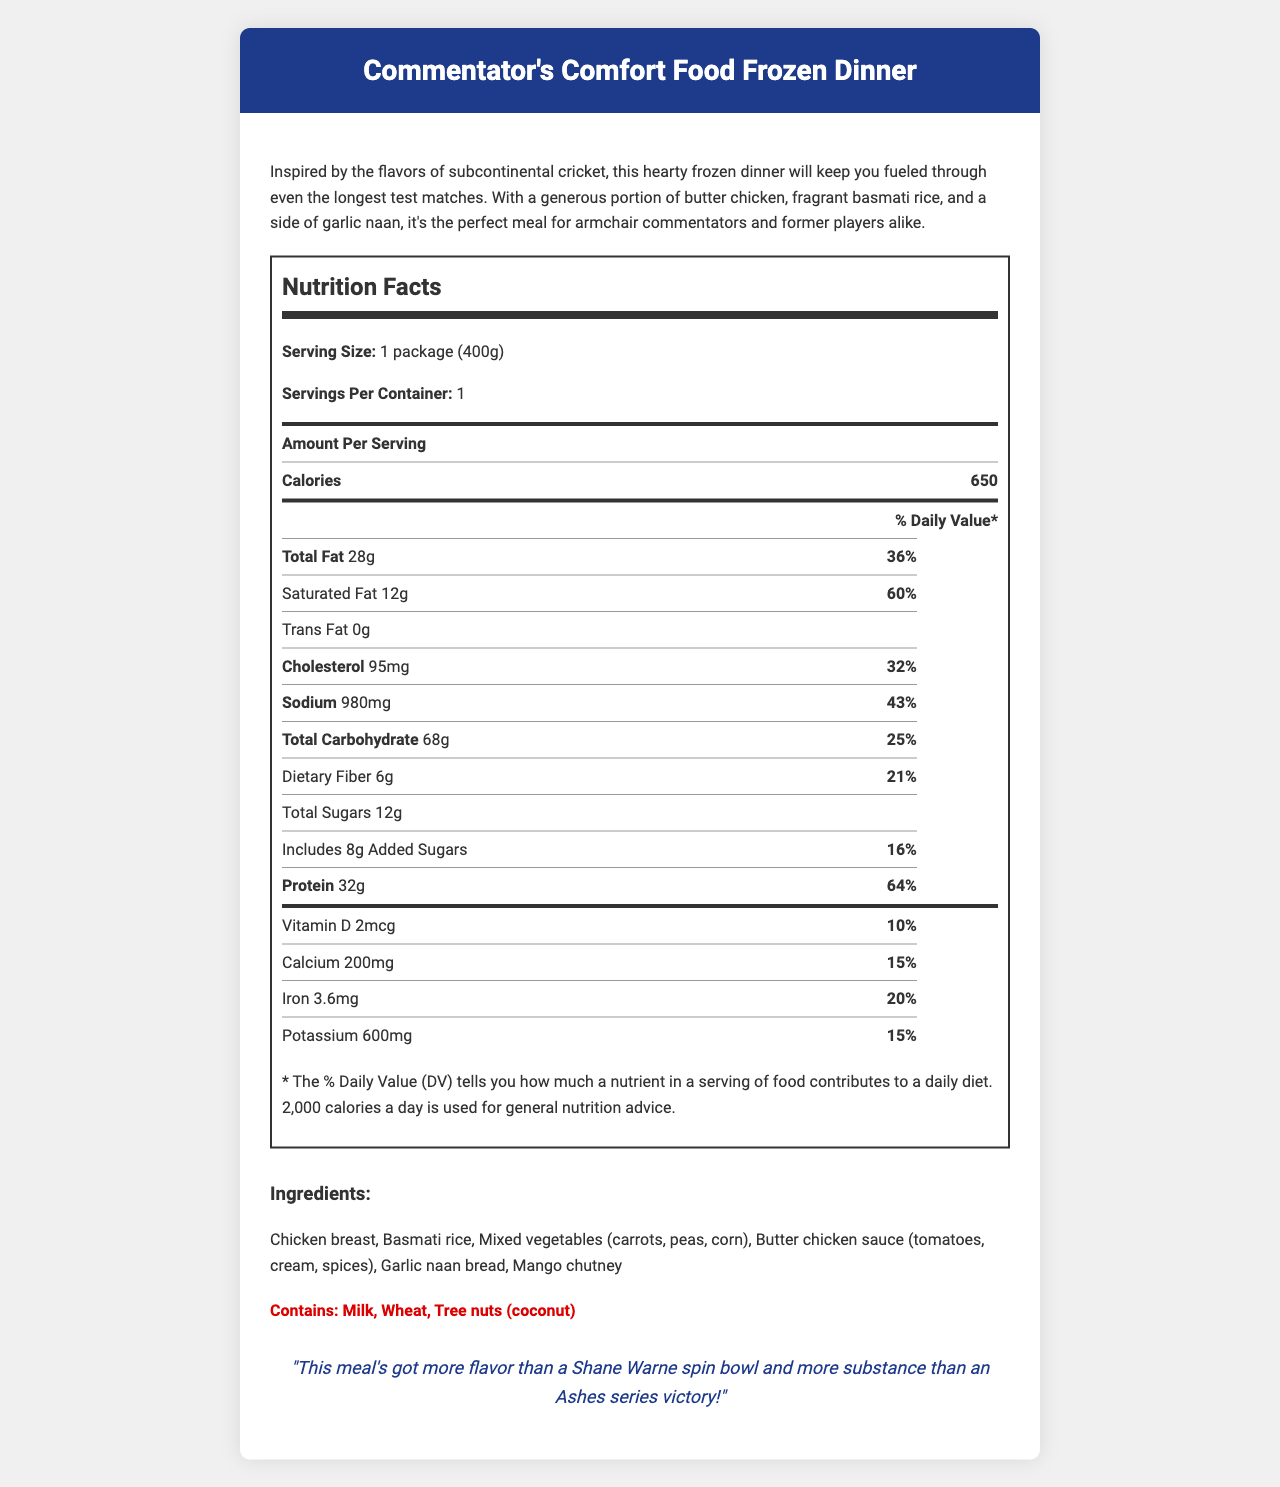what is the serving size of the frozen dinner? The document states the serving size is "1 package (400g)."
Answer: 1 package (400g) how many calories does one serving of the frozen dinner provide? The document lists the calorie content per serving as 650 calories.
Answer: 650 how much total fat is in the frozen dinner? The document indicates that there are 28 grams of total fat in one serving.
Answer: 28g what percentage of daily value does saturated fat constitute? The document specifies that the daily value percentage of saturated fat is 60%.
Answer: 60% what are the main ingredients in the frozen dinner? The document lists these items as ingredients under the ingredients section.
Answer: Chicken breast, Basmati rice, Mixed vegetables (carrots, peas, corn), Butter chicken sauce (tomatoes, cream, spices), Garlic naan bread, Mango chutney which nutrient has the highest daily value percentage? A. Saturated Fat B. Cholesterol C. Sodium D. Protein Nutrient daily values listed are Saturated Fat (60%), Cholesterol (32%), Sodium (43%), and Protein (64%). Protein has the highest daily value percentage at 64%.
Answer: D. Protein how many grams of dietary fiber does the frozen dinner provide? A. 5g B. 6g C. 7g D. 8g The document shows that the frozen dinner contains 6 grams of dietary fiber.
Answer: B. 6g does the frozen dinner contain any trans fat? The document specifies that the trans fat content is 0 grams.
Answer: No summarize the document's main idea. The document outlines the nutritional content, daily value percentages, ingredients, and allergens of the frozen dinner, alongside a humorous commentary quip and a product description emphasizing its rich flavors and substantial portion size.
Answer: The document provides detailed nutrition facts, ingredients, allergens, and a product description of the "Commentator's Comfort Food Frozen Dinner," which is inspired by subcontinental cricket flavors. how many grams of added sugars are in the frozen dinner? The document states that there are 8 grams of added sugars in the frozen dinner.
Answer: 8g how much potassium is in the frozen dinner in mg and what is the daily value percentage? The document lists 600 mg of potassium which constitutes 15% of the daily value.
Answer: 600 mg, 15% what allergens are present in the frozen dinner? The document mentions these allergens in the allergen section.
Answer: Milk, Wheat, Tree nuts (coconut) what type of rice is included in the frozen dinner? The ingredients section lists Basmati rice as part of the dish.
Answer: Basmati rice describe the calories and macronutrient content of the frozen dinner. These values are stated directly under the nutrition facts section of the document.
Answer: The frozen dinner contains 650 calories, 28 grams of total fat, 12 grams of saturated fat, 0 grams of trans fat, 68 grams of total carbohydrates, 6 grams of dietary fiber, 12 grams of total sugars, 8 grams of added sugars, and 32 grams of protein. how much cholesterol does the frozen dinner contain in mg? The document specifies that there are 95 mg of cholesterol in the frozen dinner.
Answer: 95 mg what is the unique quip associated with the frozen dinner? The document includes this humorous quote in the quip section.
Answer: "This meal's got more flavor than a Shane Warne spin bowl and more substance than an Ashes series victory!" can the total revenue of the product be determined from the document? The document does not provide any information related to the sales or revenue of the product.
Answer: Cannot be determined 